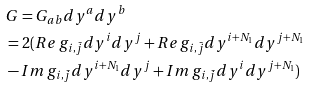Convert formula to latex. <formula><loc_0><loc_0><loc_500><loc_500>& G = G _ { a b } d y ^ { a } d y ^ { b } \\ & = 2 ( R e \, g _ { i , \bar { j } } d y ^ { i } d y ^ { j } + R e \, g _ { i , \bar { j } } d y ^ { i + N _ { 1 } } d y ^ { j + N _ { 1 } } \\ & - I m \, g _ { i , \bar { j } } d y ^ { i + N _ { 1 } } d y ^ { j } + I m \, g _ { i , \bar { j } } d y ^ { i } d y ^ { j + N _ { 1 } } )</formula> 